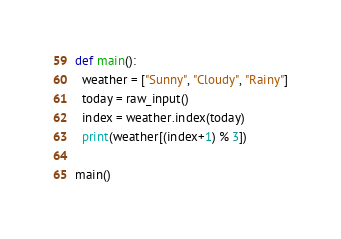<code> <loc_0><loc_0><loc_500><loc_500><_Python_>def main():
  weather = ["Sunny", "Cloudy", "Rainy"]
  today = raw_input()
  index = weather.index(today)
  print(weather[(index+1) % 3])

main()</code> 